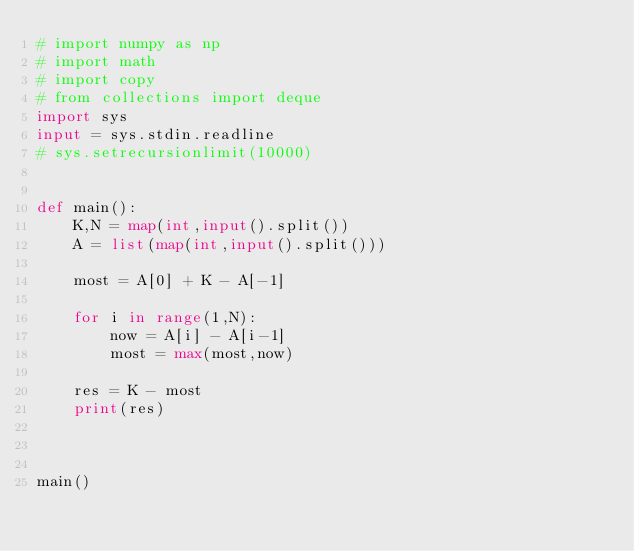Convert code to text. <code><loc_0><loc_0><loc_500><loc_500><_Python_># import numpy as np
# import math
# import copy
# from collections import deque
import sys
input = sys.stdin.readline
# sys.setrecursionlimit(10000)


def main():
    K,N = map(int,input().split())
    A = list(map(int,input().split()))

    most = A[0] + K - A[-1]

    for i in range(1,N):
        now = A[i] - A[i-1]
        most = max(most,now)

    res = K - most
    print(res)



main()
</code> 